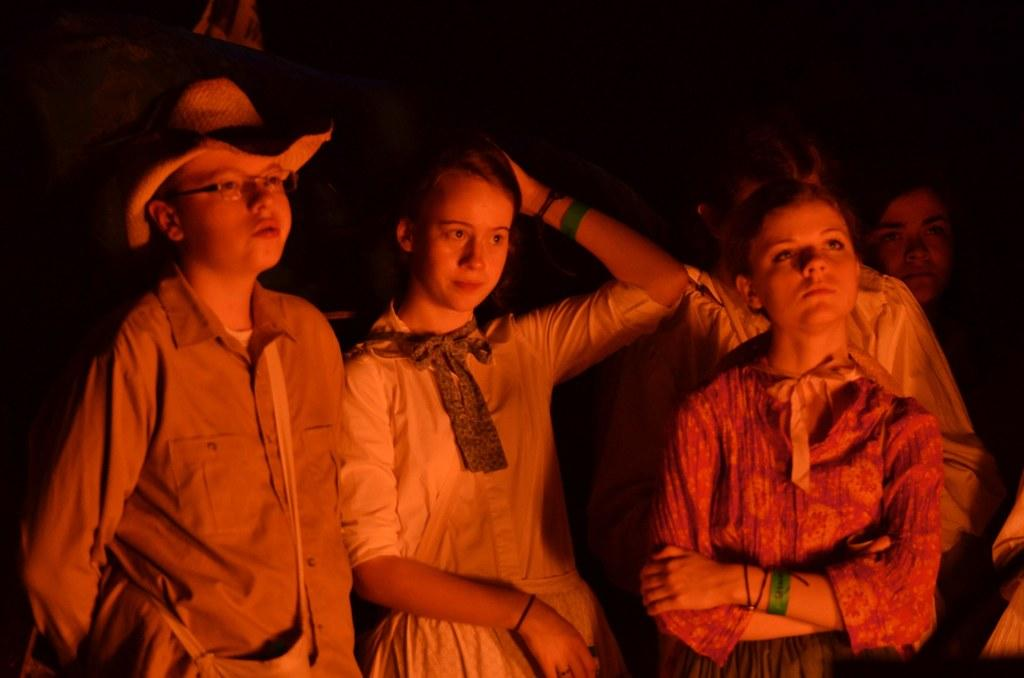What is the main subject of the image? There is a person in the image. Can you describe the person's clothing? The person is wearing a shirt, spectacles, and a hat. Are there any other people in the image? Yes, there are people standing in the image. What can be observed about the background of the image? The background of the image is dark. What type of unit is being measured on the sheet in the image? There is no sheet or unit measurement present in the image. What day is it in the image? The image does not provide any information about the day or date. 